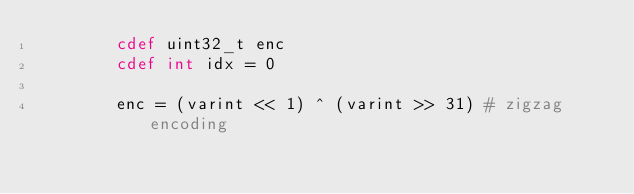<code> <loc_0><loc_0><loc_500><loc_500><_Cython_>        cdef uint32_t enc
        cdef int idx = 0

        enc = (varint << 1) ^ (varint >> 31) # zigzag encoding</code> 